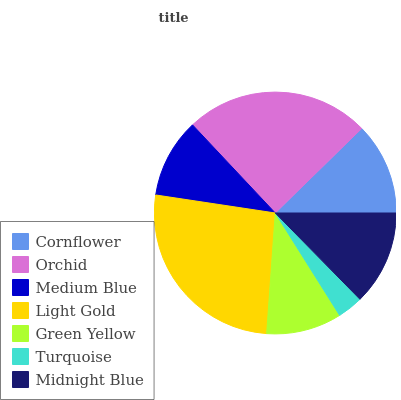Is Turquoise the minimum?
Answer yes or no. Yes. Is Light Gold the maximum?
Answer yes or no. Yes. Is Orchid the minimum?
Answer yes or no. No. Is Orchid the maximum?
Answer yes or no. No. Is Orchid greater than Cornflower?
Answer yes or no. Yes. Is Cornflower less than Orchid?
Answer yes or no. Yes. Is Cornflower greater than Orchid?
Answer yes or no. No. Is Orchid less than Cornflower?
Answer yes or no. No. Is Cornflower the high median?
Answer yes or no. Yes. Is Cornflower the low median?
Answer yes or no. Yes. Is Light Gold the high median?
Answer yes or no. No. Is Medium Blue the low median?
Answer yes or no. No. 